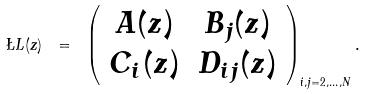<formula> <loc_0><loc_0><loc_500><loc_500>\L L ( z ) \ = \ \left ( \begin{array} { c c } A ( z ) & B _ { j } ( z ) \\ C _ { i } ( z ) & D _ { i j } ( z ) \end{array} \right ) _ { i , j = 2 , \dots , N } .</formula> 